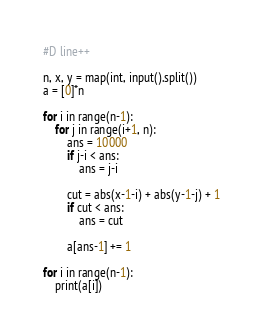Convert code to text. <code><loc_0><loc_0><loc_500><loc_500><_Python_>#D line++

n, x, y = map(int, input().split())
a = [0]*n

for i in range(n-1):
    for j in range(i+1, n):
        ans = 10000
        if j-i < ans:
            ans = j-i
        
        cut = abs(x-1-i) + abs(y-1-j) + 1
        if cut < ans:
            ans = cut
        
        a[ans-1] += 1

for i in range(n-1):
    print(a[i])

</code> 